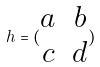<formula> <loc_0><loc_0><loc_500><loc_500>h = ( \begin{matrix} a & b \\ c & d \end{matrix} )</formula> 